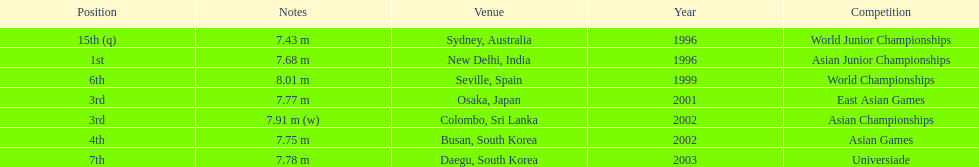Which competition did this person compete in immediately before the east asian games in 2001? World Championships. 